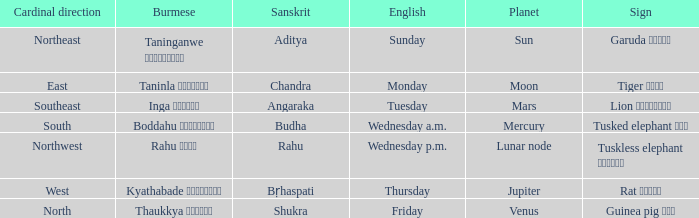What is the Burmese term associated with a cardinal direction of west? Kyathabade ကြာသပတေး. 